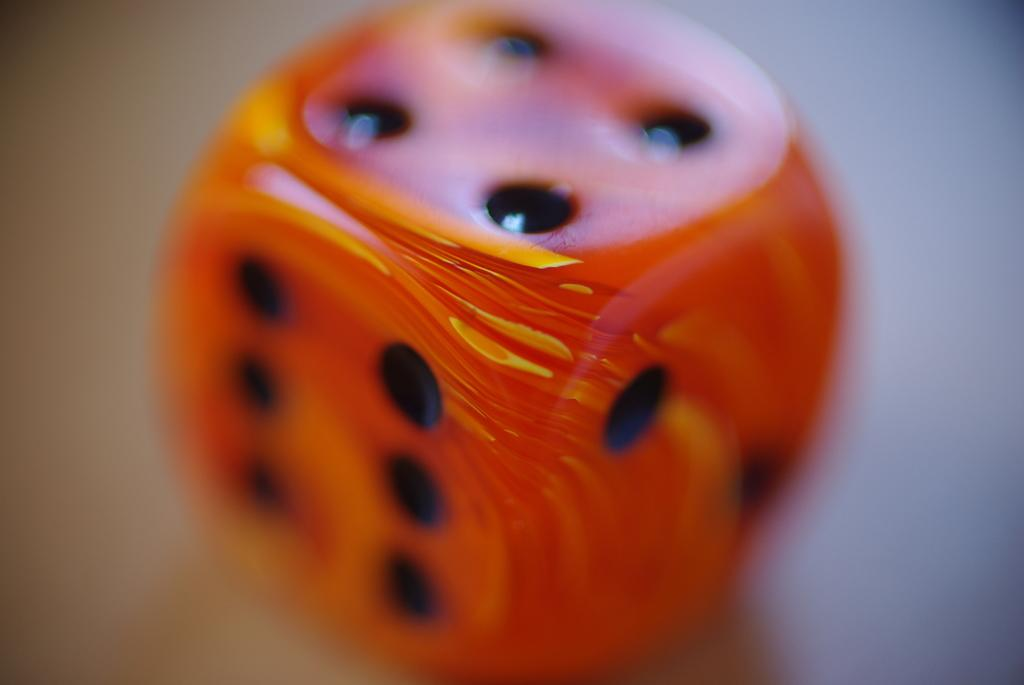What is the main object in the center of the image? There is a dice in the center of the image. What month is depicted on the veil covering the dice in the image? There is no veil or any indication of a month in the image; it only features a dice. 